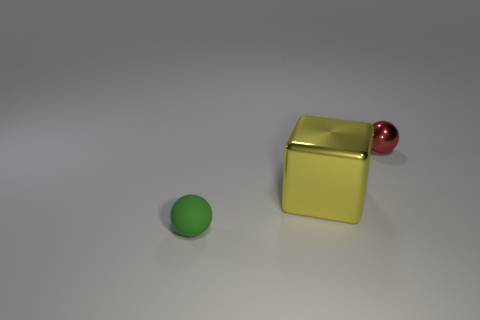Add 1 tiny green things. How many objects exist? 4 Subtract all balls. How many objects are left? 1 Add 2 red spheres. How many red spheres exist? 3 Subtract 0 purple cubes. How many objects are left? 3 Subtract all small metal spheres. Subtract all big shiny cubes. How many objects are left? 1 Add 2 tiny red balls. How many tiny red balls are left? 3 